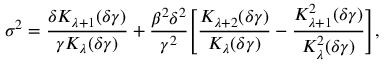<formula> <loc_0><loc_0><loc_500><loc_500>\sigma ^ { 2 } = \frac { \delta K _ { \lambda + 1 } ( \delta \gamma ) } { \gamma K _ { \lambda } ( \delta \gamma ) } + \frac { \beta ^ { 2 } \delta ^ { 2 } } { \gamma ^ { 2 } } \left [ \frac { K _ { \lambda + 2 } ( \delta \gamma ) } { K _ { \lambda } ( \delta \gamma ) } - \frac { K _ { \lambda + 1 } ^ { 2 } ( \delta \gamma ) } { K _ { \lambda } ^ { 2 } ( \delta \gamma ) } \right ] ,</formula> 